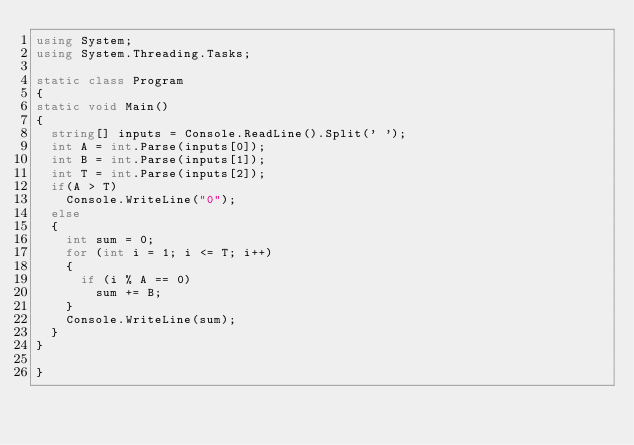<code> <loc_0><loc_0><loc_500><loc_500><_C#_>using System;
using System.Threading.Tasks;

static class Program
{
static void Main()
{
  string[] inputs = Console.ReadLine().Split(' ');
  int A = int.Parse(inputs[0]);
  int B = int.Parse(inputs[1]);
  int T = int.Parse(inputs[2]);
  if(A > T)
    Console.WriteLine("0");
  else
  {
    int sum = 0;
    for (int i = 1; i <= T; i++)
    {
      if (i % A == 0)
        sum += B;
    }
    Console.WriteLine(sum);
  }
}

}</code> 